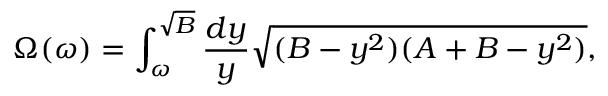<formula> <loc_0><loc_0><loc_500><loc_500>\Omega ( \omega ) = \int _ { \omega } ^ { \sqrt { B } } { \frac { d y } { y } } \sqrt { ( B - y ^ { 2 } ) ( A + B - y ^ { 2 } ) } ,</formula> 